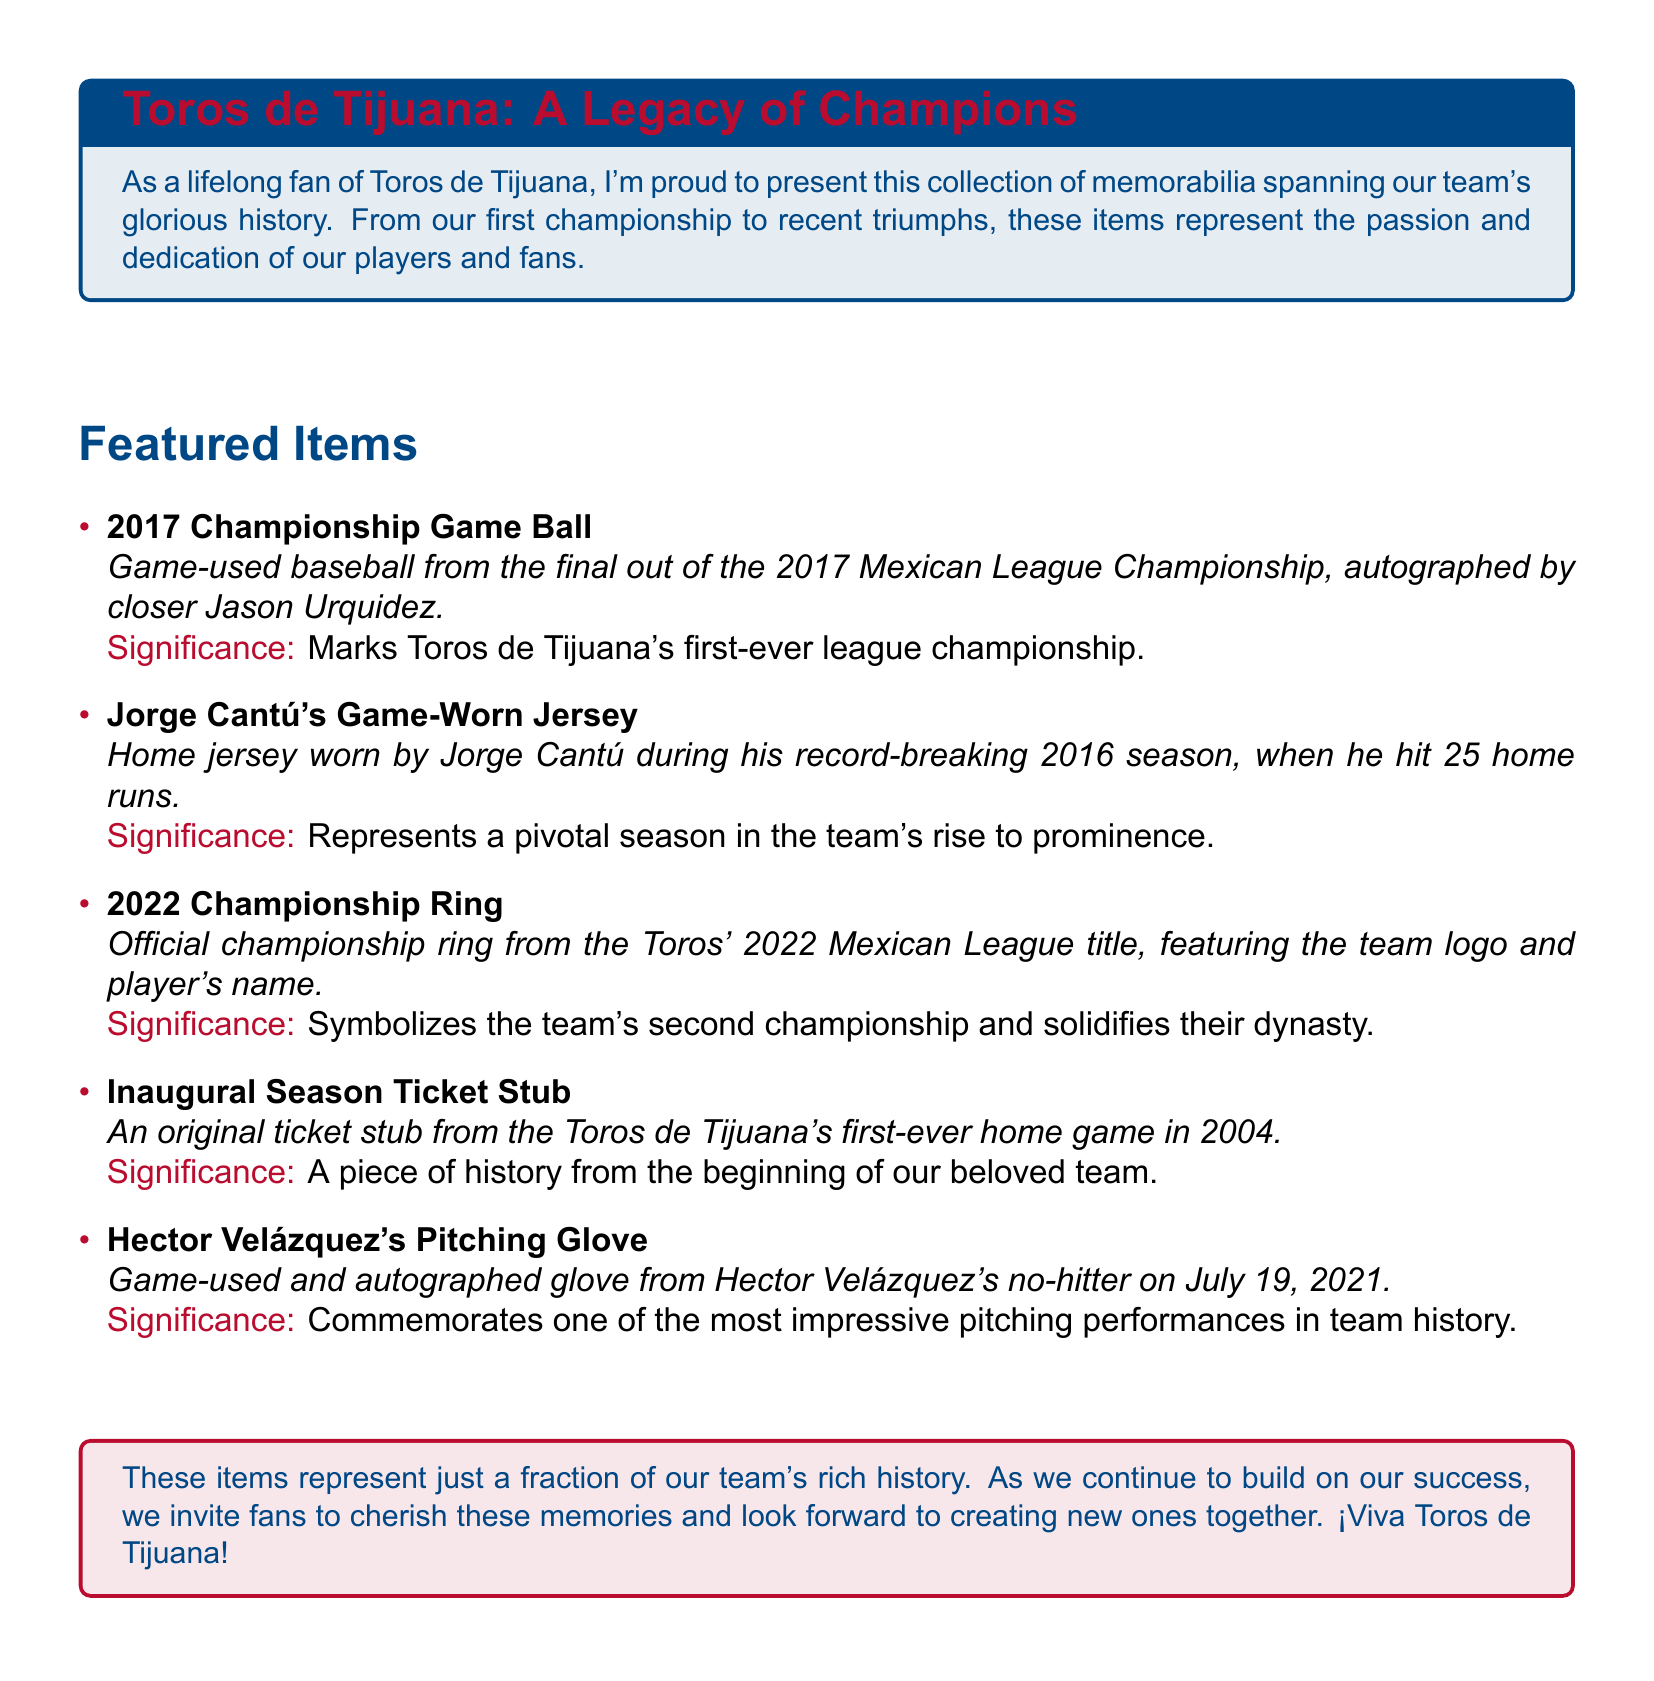What year did the Toros de Tijuana win their first championship? The document states that the 2017 Championship Game marks the Toros' first-ever league championship.
Answer: 2017 Who signed the 2017 Championship Game Ball? The document mentions the ball is autographed by closer Jason Urquidez.
Answer: Jason Urquidez What significant event is commemorated by Hector Velázquez's game's used glove? The glove is from Hector Velázquez's no-hitter on July 19, 2021, which is a notable performance in team history.
Answer: No-hitter What is the feature of the 2022 Championship Ring? The document specifies the ring features the team logo and player's name.
Answer: Team logo and player's name How many home runs did Jorge Cantú hit in his record-breaking 2016 season? The item description states he hit 25 home runs during the 2016 season.
Answer: 25 What year was the inaugural season ticket stub from? The document indicates the stub is from the Toros de Tijuana's first-ever home game in 2004.
Answer: 2004 What does the 2022 Championship Ring symbolize for the team? According to the document, it symbolizes the team's second championship and solidifies their dynasty.
Answer: Second championship What is the significance of the Inaugural Season Ticket Stub? The document notes it is a piece of history from the beginning of the team.
Answer: Piece of history 